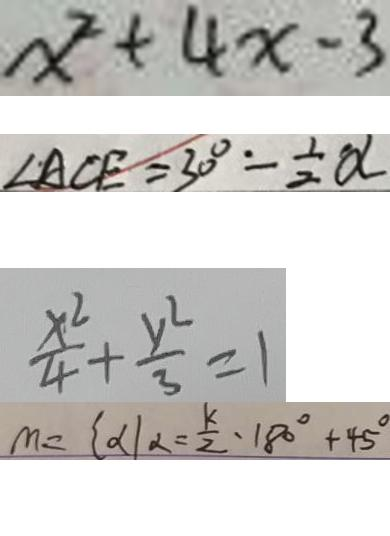<formula> <loc_0><loc_0><loc_500><loc_500>x ^ { 2 } + 4 x - 3 
 \angle A C E = 3 0 ^ { \circ } - \frac { 1 } { 2 } \alpha 
 \frac { x ^ { 2 } } { 4 } + \frac { y ^ { 2 } } { 3 } = 1 
 m = \{ \alpha \vert \alpha = \frac { k } { 2 } \cdot 1 8 0 ^ { \circ } + 4 5 ^ { \circ }</formula> 